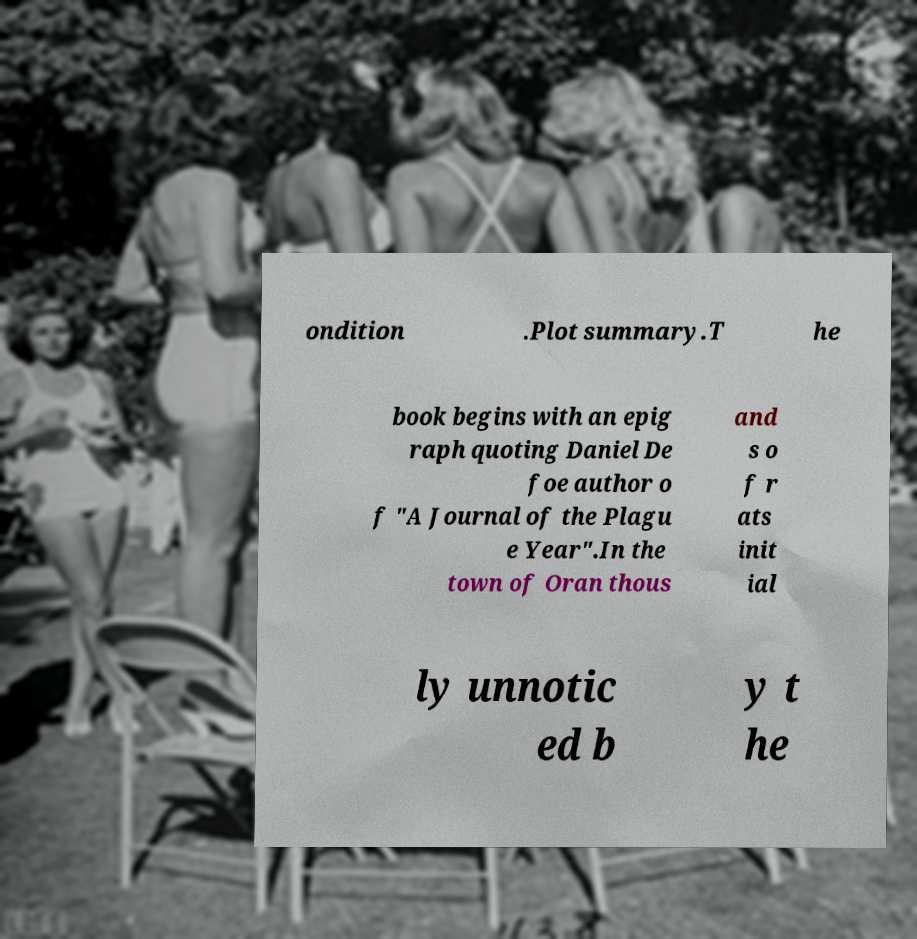I need the written content from this picture converted into text. Can you do that? ondition .Plot summary.T he book begins with an epig raph quoting Daniel De foe author o f "A Journal of the Plagu e Year".In the town of Oran thous and s o f r ats init ial ly unnotic ed b y t he 